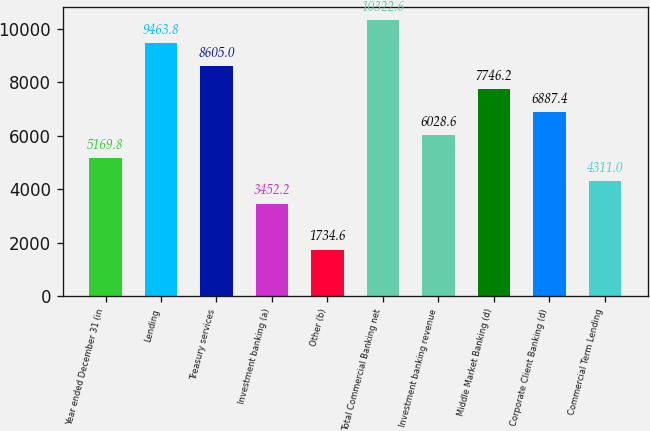Convert chart. <chart><loc_0><loc_0><loc_500><loc_500><bar_chart><fcel>Year ended December 31 (in<fcel>Lending<fcel>Treasury services<fcel>Investment banking (a)<fcel>Other (b)<fcel>Total Commercial Banking net<fcel>Investment banking revenue<fcel>Middle Market Banking (d)<fcel>Corporate Client Banking (d)<fcel>Commercial Term Lending<nl><fcel>5169.8<fcel>9463.8<fcel>8605<fcel>3452.2<fcel>1734.6<fcel>10322.6<fcel>6028.6<fcel>7746.2<fcel>6887.4<fcel>4311<nl></chart> 